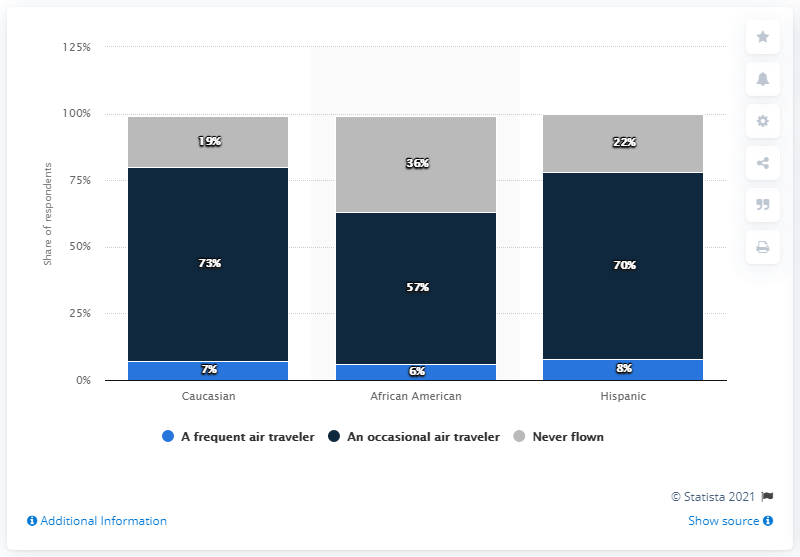Indicate a few pertinent items in this graphic. The frequency of air travel among African Americans in the United States was high, with 6% of this population group reporting that they had traveled by air at least once per week as of June 2015. According to data from June 2015, African Americans in the United States have a relatively low frequency of air travel compared to the general population, with a reported 42% having never flown. 